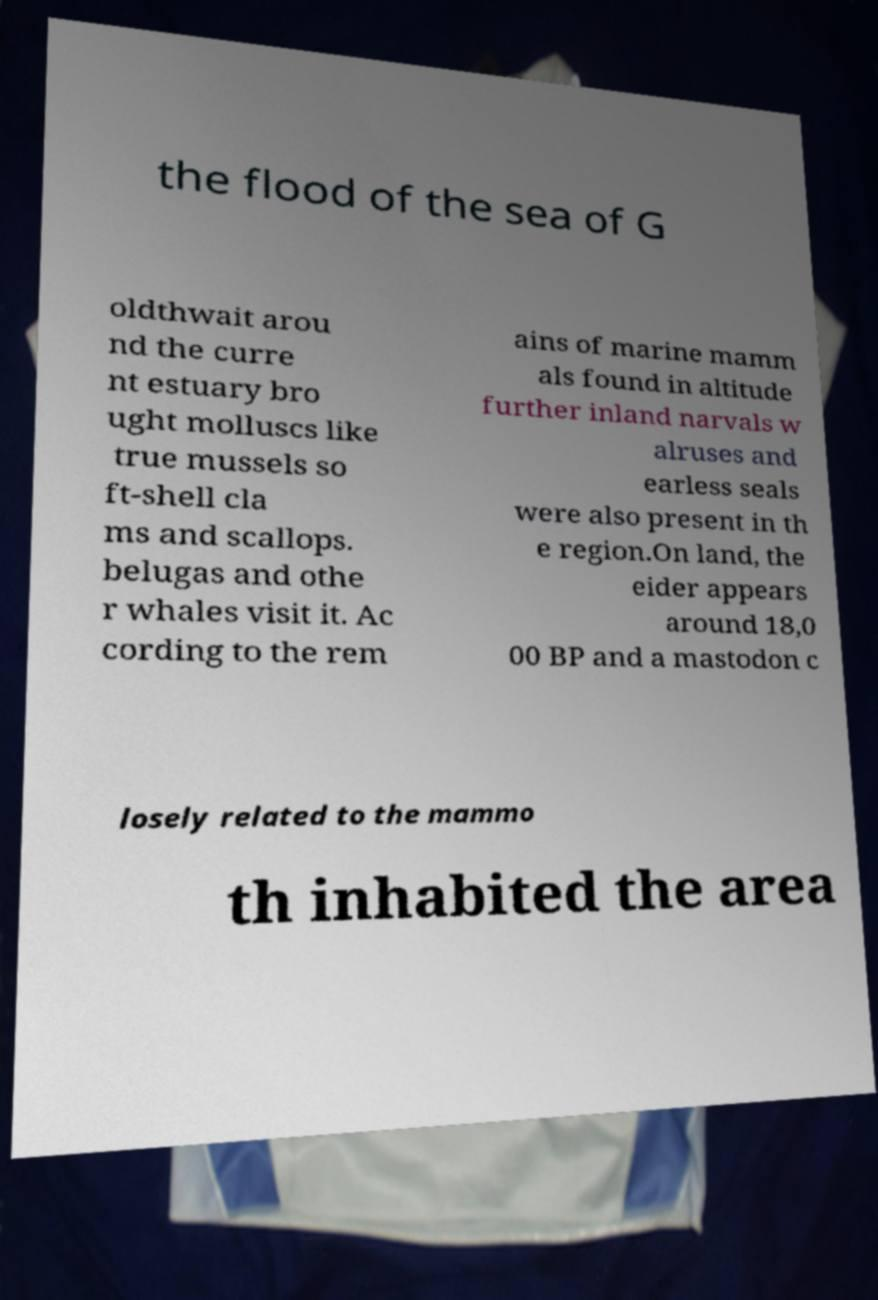Could you extract and type out the text from this image? the flood of the sea of G oldthwait arou nd the curre nt estuary bro ught molluscs like true mussels so ft-shell cla ms and scallops. belugas and othe r whales visit it. Ac cording to the rem ains of marine mamm als found in altitude further inland narvals w alruses and earless seals were also present in th e region.On land, the eider appears around 18,0 00 BP and a mastodon c losely related to the mammo th inhabited the area 